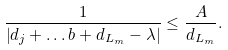<formula> <loc_0><loc_0><loc_500><loc_500>\frac { 1 } { \left | d _ { j } + \dots b + d _ { L _ { m } } - \lambda \right | } \leq \frac { A } { d _ { L _ { m } } } .</formula> 